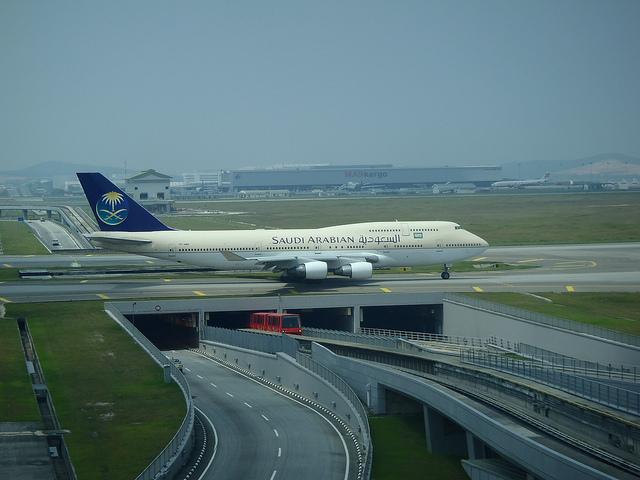What color is the bus?
Answer briefly. Red. What structure is in the background?
Answer briefly. Airport. What part of the world does this airplane come from?
Answer briefly. Saudi arabia. 